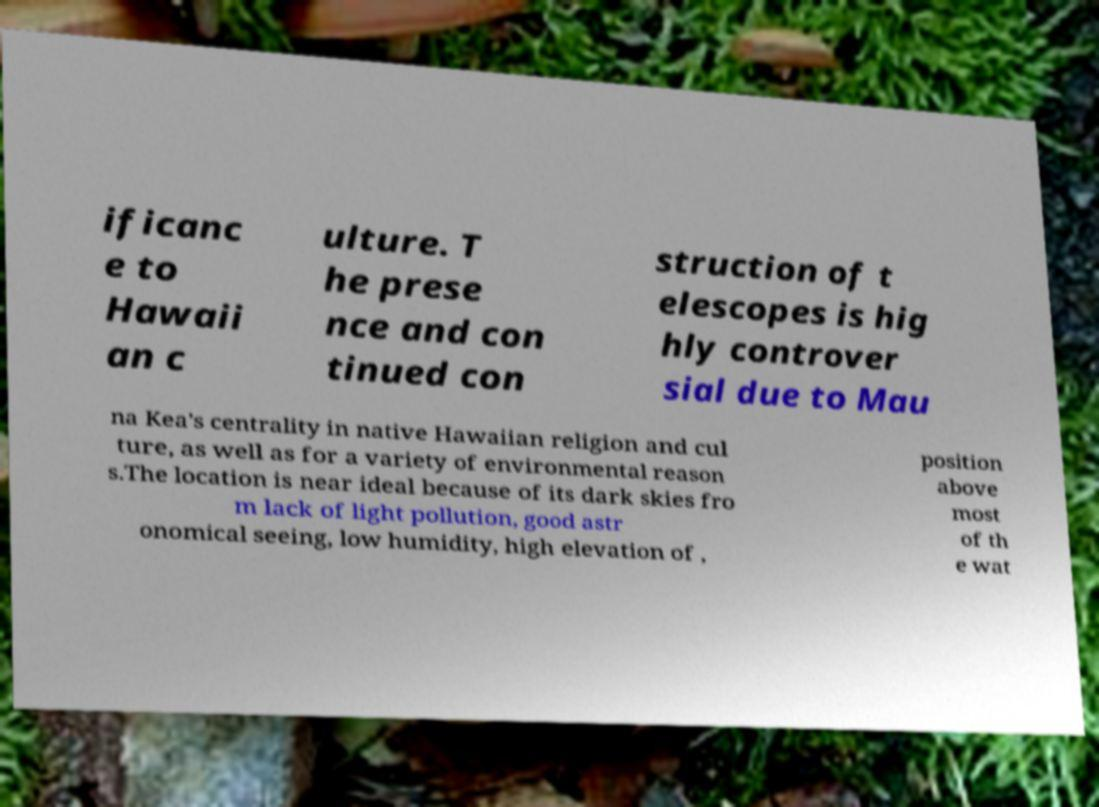Could you assist in decoding the text presented in this image and type it out clearly? ificanc e to Hawaii an c ulture. T he prese nce and con tinued con struction of t elescopes is hig hly controver sial due to Mau na Kea's centrality in native Hawaiian religion and cul ture, as well as for a variety of environmental reason s.The location is near ideal because of its dark skies fro m lack of light pollution, good astr onomical seeing, low humidity, high elevation of , position above most of th e wat 